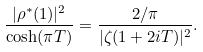Convert formula to latex. <formula><loc_0><loc_0><loc_500><loc_500>\frac { | \rho ^ { * } ( 1 ) | ^ { 2 } } { \cosh ( \pi T ) } = \frac { 2 / \pi } { | \zeta ( 1 + 2 i T ) | ^ { 2 } } .</formula> 